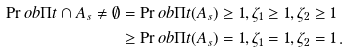Convert formula to latex. <formula><loc_0><loc_0><loc_500><loc_500>\Pr o b { \Pi t \cap A _ { s } \ne \emptyset } & = \Pr o b { \Pi t ( A _ { s } ) \geq 1 , \zeta _ { 1 } \geq 1 , \zeta _ { 2 } \geq 1 } \\ & \geq \Pr o b { \Pi t ( A _ { s } ) = 1 , \zeta _ { 1 } = 1 , \zeta _ { 2 } = 1 } \, .</formula> 